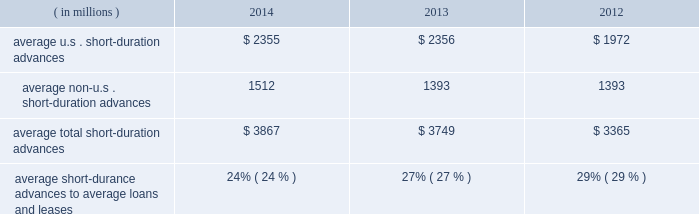Management 2019s discussion and analysis of financial condition and results of operations ( continued ) detail with respect to our investment portfolio as of december 31 , 2014 and 2013 is provided in note 3 to the consolidated financial statements included under item 8 of this form 10-k .
Loans and leases averaged $ 15.91 billion for the year ended 2014 , up from $ 13.78 billion in 2013 .
The increase was mainly related to mutual fund lending and our continued investment in senior secured bank loans .
Mutual fund lending and senior secured bank loans averaged approximately $ 9.12 billion and $ 1.40 billion , respectively , for the year ended december 31 , 2014 compared to $ 8.16 billion and $ 170 million for the year ended december 31 , 2013 , respectively .
Average loans and leases also include short- duration advances .
Table 13 : u.s .
And non-u.s .
Short-duration advances years ended december 31 .
Average u.s .
Short-duration advances $ 2355 $ 2356 $ 1972 average non-u.s .
Short-duration advances 1512 1393 1393 average total short-duration advances $ 3867 $ 3749 $ 3365 average short-durance advances to average loans and leases 24% ( 24 % ) 27% ( 27 % ) 29% ( 29 % ) the decline in proportion of the average daily short-duration advances to average loans and leases is primarily due to growth in the other segments of the loan and lease portfolio .
Short-duration advances provide liquidity to clients in support of their investment activities .
Although average short-duration advances for the year ended december 31 , 2014 increased compared to the year ended december 31 , 2013 , such average advances remained low relative to historical levels , mainly the result of clients continuing to hold higher levels of liquidity .
Average other interest-earning assets increased to $ 15.94 billion for the year ended december 31 , 2014 from $ 11.16 billion for the year ended december 31 , 2013 .
The increased levels were primarily the result of higher levels of cash collateral provided in connection with our enhanced custody business .
Aggregate average interest-bearing deposits increased to $ 130.30 billion for the year ended december 31 , 2014 from $ 109.25 billion for year ended 2013 .
The higher levels were primarily the result of increases in both u.s .
And non-u.s .
Transaction accounts and time deposits .
Future transaction account levels will be influenced by the underlying asset servicing business , as well as market conditions , including the general levels of u.s .
And non-u.s .
Interest rates .
Average other short-term borrowings increased to $ 4.18 billion for the year ended december 31 , 2014 from $ 3.79 billion for the year ended 2013 .
The increase was the result of a higher level of client demand for our commercial paper .
The decline in rates paid from 1.6% ( 1.6 % ) in 2013 to 0.1% ( 0.1 % ) in 2014 resulted from a reclassification of certain derivative contracts that hedge our interest-rate risk on certain assets and liabilities , which reduced interest revenue and interest expense .
Average long-term debt increased to $ 9.31 billion for the year ended december 31 , 2014 from $ 8.42 billion for the year ended december 31 , 2013 .
The increase primarily reflected the issuance of $ 1.5 billion of senior and subordinated debt in may 2013 , $ 1.0 billion of senior debt issued in november 2013 , and $ 1.0 billion of senior debt issued in december 2014 .
This is partially offset by the maturities of $ 500 million of senior debt in may 2014 and $ 250 million of senior debt in march 2014 .
Average other interest-bearing liabilities increased to $ 7.35 billion for the year ended december 31 , 2014 from $ 6.46 billion for the year ended december 31 , 2013 , primarily the result of higher levels of cash collateral received from clients in connection with our enhanced custody business .
Several factors could affect future levels of our net interest revenue and margin , including the mix of client liabilities ; actions of various central banks ; changes in u.s .
And non-u.s .
Interest rates ; changes in the various yield curves around the world ; revised or proposed regulatory capital or liquidity standards , or interpretations of those standards ; the amount of discount accretion generated by the former conduit securities that remain in our investment securities portfolio ; and the yields earned on securities purchased compared to the yields earned on securities sold or matured .
Based on market conditions and other factors , we continue to reinvest the majority of the proceeds from pay-downs and maturities of investment securities in highly-rated securities , such as u.s .
Treasury and agency securities , municipal securities , federal agency mortgage-backed securities and u.s .
And non-u.s .
Mortgage- and asset-backed securities .
The pace at which we continue to reinvest and the types of investment securities purchased will depend on the impact of market conditions and other factors over time .
We expect these factors and the levels of global interest rates to influence what effect our reinvestment program will have on future levels of our net interest revenue and net interest margin. .
How is the cash flow statement from financing activities affected by the change in the balance of the long-term debt during 2014 , in millions? 
Computations: ((9.31 - 8.42) * 1000)
Answer: 890.0. 